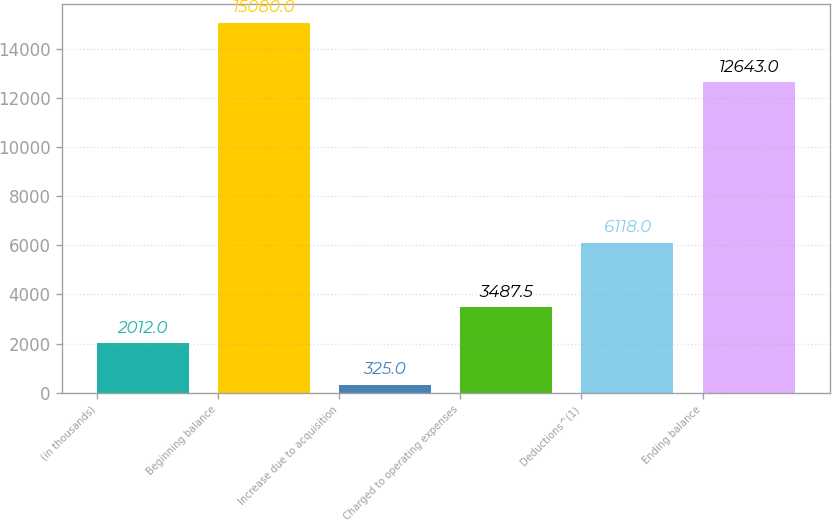Convert chart. <chart><loc_0><loc_0><loc_500><loc_500><bar_chart><fcel>(in thousands)<fcel>Beginning balance<fcel>Increase due to acquisition<fcel>Charged to operating expenses<fcel>Deductions^(1)<fcel>Ending balance<nl><fcel>2012<fcel>15080<fcel>325<fcel>3487.5<fcel>6118<fcel>12643<nl></chart> 